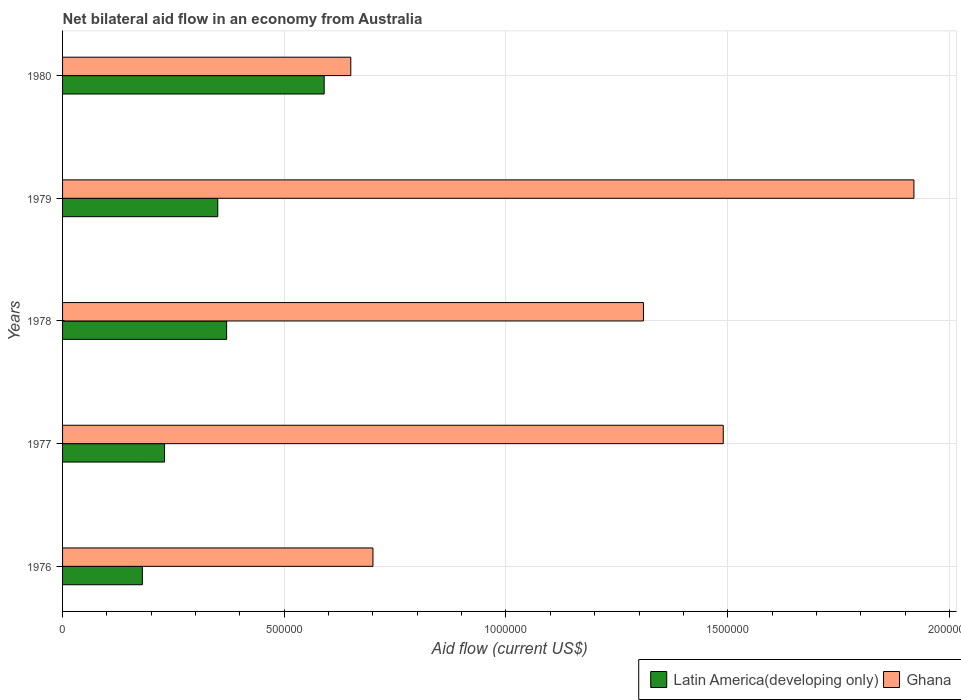How many groups of bars are there?
Provide a short and direct response. 5. Are the number of bars per tick equal to the number of legend labels?
Provide a short and direct response. Yes. Are the number of bars on each tick of the Y-axis equal?
Your response must be concise. Yes. How many bars are there on the 3rd tick from the top?
Your response must be concise. 2. What is the label of the 3rd group of bars from the top?
Offer a very short reply. 1978. What is the net bilateral aid flow in Ghana in 1980?
Provide a short and direct response. 6.50e+05. Across all years, what is the maximum net bilateral aid flow in Latin America(developing only)?
Offer a very short reply. 5.90e+05. Across all years, what is the minimum net bilateral aid flow in Latin America(developing only)?
Your response must be concise. 1.80e+05. In which year was the net bilateral aid flow in Latin America(developing only) maximum?
Keep it short and to the point. 1980. In which year was the net bilateral aid flow in Ghana minimum?
Provide a succinct answer. 1980. What is the total net bilateral aid flow in Ghana in the graph?
Offer a very short reply. 6.07e+06. What is the difference between the net bilateral aid flow in Ghana in 1979 and that in 1980?
Your answer should be compact. 1.27e+06. What is the difference between the net bilateral aid flow in Latin America(developing only) in 1977 and the net bilateral aid flow in Ghana in 1976?
Your response must be concise. -4.70e+05. What is the average net bilateral aid flow in Latin America(developing only) per year?
Your answer should be very brief. 3.44e+05. In the year 1976, what is the difference between the net bilateral aid flow in Ghana and net bilateral aid flow in Latin America(developing only)?
Offer a terse response. 5.20e+05. In how many years, is the net bilateral aid flow in Latin America(developing only) greater than 1900000 US$?
Make the answer very short. 0. What is the ratio of the net bilateral aid flow in Latin America(developing only) in 1977 to that in 1978?
Offer a terse response. 0.62. Is the net bilateral aid flow in Ghana in 1979 less than that in 1980?
Make the answer very short. No. Is the difference between the net bilateral aid flow in Ghana in 1977 and 1980 greater than the difference between the net bilateral aid flow in Latin America(developing only) in 1977 and 1980?
Keep it short and to the point. Yes. What is the difference between the highest and the lowest net bilateral aid flow in Latin America(developing only)?
Provide a succinct answer. 4.10e+05. In how many years, is the net bilateral aid flow in Ghana greater than the average net bilateral aid flow in Ghana taken over all years?
Keep it short and to the point. 3. What does the 2nd bar from the top in 1978 represents?
Offer a terse response. Latin America(developing only). Are all the bars in the graph horizontal?
Offer a very short reply. Yes. What is the difference between two consecutive major ticks on the X-axis?
Provide a succinct answer. 5.00e+05. Does the graph contain grids?
Provide a succinct answer. Yes. Where does the legend appear in the graph?
Give a very brief answer. Bottom right. How many legend labels are there?
Provide a succinct answer. 2. How are the legend labels stacked?
Keep it short and to the point. Horizontal. What is the title of the graph?
Your answer should be compact. Net bilateral aid flow in an economy from Australia. What is the label or title of the X-axis?
Your answer should be very brief. Aid flow (current US$). What is the Aid flow (current US$) of Latin America(developing only) in 1977?
Offer a very short reply. 2.30e+05. What is the Aid flow (current US$) of Ghana in 1977?
Make the answer very short. 1.49e+06. What is the Aid flow (current US$) in Ghana in 1978?
Offer a terse response. 1.31e+06. What is the Aid flow (current US$) of Ghana in 1979?
Your answer should be compact. 1.92e+06. What is the Aid flow (current US$) in Latin America(developing only) in 1980?
Keep it short and to the point. 5.90e+05. What is the Aid flow (current US$) of Ghana in 1980?
Give a very brief answer. 6.50e+05. Across all years, what is the maximum Aid flow (current US$) in Latin America(developing only)?
Provide a succinct answer. 5.90e+05. Across all years, what is the maximum Aid flow (current US$) in Ghana?
Offer a terse response. 1.92e+06. Across all years, what is the minimum Aid flow (current US$) in Ghana?
Your answer should be very brief. 6.50e+05. What is the total Aid flow (current US$) of Latin America(developing only) in the graph?
Your answer should be compact. 1.72e+06. What is the total Aid flow (current US$) of Ghana in the graph?
Make the answer very short. 6.07e+06. What is the difference between the Aid flow (current US$) in Latin America(developing only) in 1976 and that in 1977?
Provide a short and direct response. -5.00e+04. What is the difference between the Aid flow (current US$) of Ghana in 1976 and that in 1977?
Offer a very short reply. -7.90e+05. What is the difference between the Aid flow (current US$) of Latin America(developing only) in 1976 and that in 1978?
Provide a succinct answer. -1.90e+05. What is the difference between the Aid flow (current US$) of Ghana in 1976 and that in 1978?
Your response must be concise. -6.10e+05. What is the difference between the Aid flow (current US$) in Latin America(developing only) in 1976 and that in 1979?
Your answer should be very brief. -1.70e+05. What is the difference between the Aid flow (current US$) in Ghana in 1976 and that in 1979?
Keep it short and to the point. -1.22e+06. What is the difference between the Aid flow (current US$) in Latin America(developing only) in 1976 and that in 1980?
Offer a very short reply. -4.10e+05. What is the difference between the Aid flow (current US$) of Latin America(developing only) in 1977 and that in 1978?
Keep it short and to the point. -1.40e+05. What is the difference between the Aid flow (current US$) in Ghana in 1977 and that in 1979?
Provide a short and direct response. -4.30e+05. What is the difference between the Aid flow (current US$) in Latin America(developing only) in 1977 and that in 1980?
Provide a short and direct response. -3.60e+05. What is the difference between the Aid flow (current US$) in Ghana in 1977 and that in 1980?
Provide a succinct answer. 8.40e+05. What is the difference between the Aid flow (current US$) in Latin America(developing only) in 1978 and that in 1979?
Ensure brevity in your answer.  2.00e+04. What is the difference between the Aid flow (current US$) in Ghana in 1978 and that in 1979?
Provide a short and direct response. -6.10e+05. What is the difference between the Aid flow (current US$) of Latin America(developing only) in 1979 and that in 1980?
Your response must be concise. -2.40e+05. What is the difference between the Aid flow (current US$) of Ghana in 1979 and that in 1980?
Ensure brevity in your answer.  1.27e+06. What is the difference between the Aid flow (current US$) of Latin America(developing only) in 1976 and the Aid flow (current US$) of Ghana in 1977?
Keep it short and to the point. -1.31e+06. What is the difference between the Aid flow (current US$) in Latin America(developing only) in 1976 and the Aid flow (current US$) in Ghana in 1978?
Give a very brief answer. -1.13e+06. What is the difference between the Aid flow (current US$) of Latin America(developing only) in 1976 and the Aid flow (current US$) of Ghana in 1979?
Your answer should be very brief. -1.74e+06. What is the difference between the Aid flow (current US$) in Latin America(developing only) in 1976 and the Aid flow (current US$) in Ghana in 1980?
Your answer should be very brief. -4.70e+05. What is the difference between the Aid flow (current US$) of Latin America(developing only) in 1977 and the Aid flow (current US$) of Ghana in 1978?
Your answer should be compact. -1.08e+06. What is the difference between the Aid flow (current US$) of Latin America(developing only) in 1977 and the Aid flow (current US$) of Ghana in 1979?
Offer a terse response. -1.69e+06. What is the difference between the Aid flow (current US$) of Latin America(developing only) in 1977 and the Aid flow (current US$) of Ghana in 1980?
Provide a succinct answer. -4.20e+05. What is the difference between the Aid flow (current US$) of Latin America(developing only) in 1978 and the Aid flow (current US$) of Ghana in 1979?
Your answer should be very brief. -1.55e+06. What is the difference between the Aid flow (current US$) of Latin America(developing only) in 1978 and the Aid flow (current US$) of Ghana in 1980?
Provide a short and direct response. -2.80e+05. What is the difference between the Aid flow (current US$) in Latin America(developing only) in 1979 and the Aid flow (current US$) in Ghana in 1980?
Make the answer very short. -3.00e+05. What is the average Aid flow (current US$) of Latin America(developing only) per year?
Your answer should be very brief. 3.44e+05. What is the average Aid flow (current US$) of Ghana per year?
Your answer should be very brief. 1.21e+06. In the year 1976, what is the difference between the Aid flow (current US$) of Latin America(developing only) and Aid flow (current US$) of Ghana?
Offer a terse response. -5.20e+05. In the year 1977, what is the difference between the Aid flow (current US$) in Latin America(developing only) and Aid flow (current US$) in Ghana?
Ensure brevity in your answer.  -1.26e+06. In the year 1978, what is the difference between the Aid flow (current US$) of Latin America(developing only) and Aid flow (current US$) of Ghana?
Keep it short and to the point. -9.40e+05. In the year 1979, what is the difference between the Aid flow (current US$) of Latin America(developing only) and Aid flow (current US$) of Ghana?
Your response must be concise. -1.57e+06. What is the ratio of the Aid flow (current US$) in Latin America(developing only) in 1976 to that in 1977?
Give a very brief answer. 0.78. What is the ratio of the Aid flow (current US$) in Ghana in 1976 to that in 1977?
Provide a succinct answer. 0.47. What is the ratio of the Aid flow (current US$) in Latin America(developing only) in 1976 to that in 1978?
Provide a short and direct response. 0.49. What is the ratio of the Aid flow (current US$) of Ghana in 1976 to that in 1978?
Your answer should be compact. 0.53. What is the ratio of the Aid flow (current US$) of Latin America(developing only) in 1976 to that in 1979?
Your answer should be very brief. 0.51. What is the ratio of the Aid flow (current US$) in Ghana in 1976 to that in 1979?
Your answer should be very brief. 0.36. What is the ratio of the Aid flow (current US$) of Latin America(developing only) in 1976 to that in 1980?
Your response must be concise. 0.31. What is the ratio of the Aid flow (current US$) of Ghana in 1976 to that in 1980?
Your answer should be compact. 1.08. What is the ratio of the Aid flow (current US$) of Latin America(developing only) in 1977 to that in 1978?
Ensure brevity in your answer.  0.62. What is the ratio of the Aid flow (current US$) of Ghana in 1977 to that in 1978?
Your answer should be very brief. 1.14. What is the ratio of the Aid flow (current US$) in Latin America(developing only) in 1977 to that in 1979?
Your answer should be compact. 0.66. What is the ratio of the Aid flow (current US$) of Ghana in 1977 to that in 1979?
Offer a very short reply. 0.78. What is the ratio of the Aid flow (current US$) in Latin America(developing only) in 1977 to that in 1980?
Your answer should be very brief. 0.39. What is the ratio of the Aid flow (current US$) in Ghana in 1977 to that in 1980?
Provide a succinct answer. 2.29. What is the ratio of the Aid flow (current US$) of Latin America(developing only) in 1978 to that in 1979?
Offer a terse response. 1.06. What is the ratio of the Aid flow (current US$) in Ghana in 1978 to that in 1979?
Offer a very short reply. 0.68. What is the ratio of the Aid flow (current US$) in Latin America(developing only) in 1978 to that in 1980?
Give a very brief answer. 0.63. What is the ratio of the Aid flow (current US$) in Ghana in 1978 to that in 1980?
Make the answer very short. 2.02. What is the ratio of the Aid flow (current US$) in Latin America(developing only) in 1979 to that in 1980?
Ensure brevity in your answer.  0.59. What is the ratio of the Aid flow (current US$) in Ghana in 1979 to that in 1980?
Keep it short and to the point. 2.95. What is the difference between the highest and the lowest Aid flow (current US$) in Latin America(developing only)?
Make the answer very short. 4.10e+05. What is the difference between the highest and the lowest Aid flow (current US$) in Ghana?
Ensure brevity in your answer.  1.27e+06. 